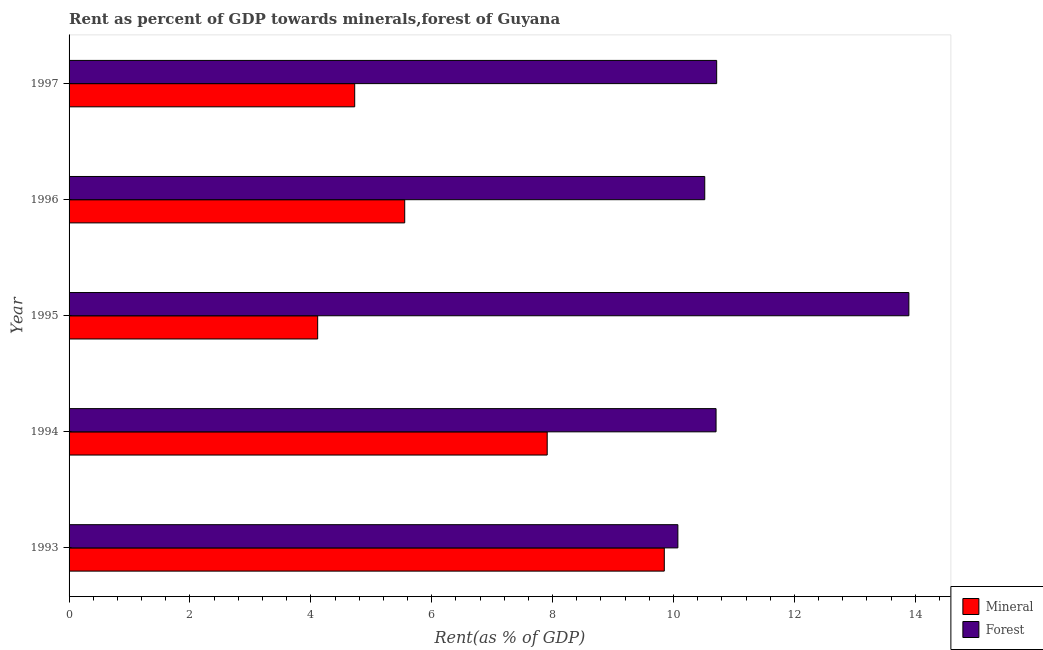How many groups of bars are there?
Make the answer very short. 5. Are the number of bars per tick equal to the number of legend labels?
Give a very brief answer. Yes. Are the number of bars on each tick of the Y-axis equal?
Provide a succinct answer. Yes. What is the mineral rent in 1996?
Provide a short and direct response. 5.55. Across all years, what is the maximum mineral rent?
Offer a very short reply. 9.85. Across all years, what is the minimum forest rent?
Make the answer very short. 10.07. In which year was the forest rent minimum?
Keep it short and to the point. 1993. What is the total mineral rent in the graph?
Your answer should be very brief. 32.15. What is the difference between the mineral rent in 1993 and that in 1997?
Offer a very short reply. 5.12. What is the difference between the mineral rent in 1995 and the forest rent in 1994?
Provide a succinct answer. -6.59. What is the average forest rent per year?
Give a very brief answer. 11.18. In the year 1996, what is the difference between the forest rent and mineral rent?
Your answer should be compact. 4.96. What is the ratio of the mineral rent in 1994 to that in 1995?
Offer a very short reply. 1.92. Is the mineral rent in 1993 less than that in 1997?
Provide a succinct answer. No. What is the difference between the highest and the second highest forest rent?
Keep it short and to the point. 3.18. What is the difference between the highest and the lowest mineral rent?
Offer a very short reply. 5.73. In how many years, is the mineral rent greater than the average mineral rent taken over all years?
Ensure brevity in your answer.  2. Is the sum of the mineral rent in 1993 and 1995 greater than the maximum forest rent across all years?
Your answer should be very brief. Yes. What does the 2nd bar from the top in 1993 represents?
Ensure brevity in your answer.  Mineral. What does the 1st bar from the bottom in 1994 represents?
Provide a succinct answer. Mineral. How many bars are there?
Your answer should be very brief. 10. Are all the bars in the graph horizontal?
Your response must be concise. Yes. Are the values on the major ticks of X-axis written in scientific E-notation?
Offer a very short reply. No. Does the graph contain any zero values?
Your response must be concise. No. Does the graph contain grids?
Provide a short and direct response. No. Where does the legend appear in the graph?
Provide a succinct answer. Bottom right. How are the legend labels stacked?
Keep it short and to the point. Vertical. What is the title of the graph?
Make the answer very short. Rent as percent of GDP towards minerals,forest of Guyana. Does "Working capital" appear as one of the legend labels in the graph?
Your response must be concise. No. What is the label or title of the X-axis?
Ensure brevity in your answer.  Rent(as % of GDP). What is the Rent(as % of GDP) in Mineral in 1993?
Provide a short and direct response. 9.85. What is the Rent(as % of GDP) of Forest in 1993?
Ensure brevity in your answer.  10.07. What is the Rent(as % of GDP) of Mineral in 1994?
Make the answer very short. 7.91. What is the Rent(as % of GDP) in Forest in 1994?
Give a very brief answer. 10.7. What is the Rent(as % of GDP) in Mineral in 1995?
Offer a terse response. 4.11. What is the Rent(as % of GDP) of Forest in 1995?
Ensure brevity in your answer.  13.89. What is the Rent(as % of GDP) in Mineral in 1996?
Offer a very short reply. 5.55. What is the Rent(as % of GDP) in Forest in 1996?
Offer a very short reply. 10.52. What is the Rent(as % of GDP) of Mineral in 1997?
Keep it short and to the point. 4.73. What is the Rent(as % of GDP) in Forest in 1997?
Give a very brief answer. 10.71. Across all years, what is the maximum Rent(as % of GDP) of Mineral?
Your answer should be compact. 9.85. Across all years, what is the maximum Rent(as % of GDP) of Forest?
Your answer should be very brief. 13.89. Across all years, what is the minimum Rent(as % of GDP) of Mineral?
Keep it short and to the point. 4.11. Across all years, what is the minimum Rent(as % of GDP) in Forest?
Give a very brief answer. 10.07. What is the total Rent(as % of GDP) of Mineral in the graph?
Provide a succinct answer. 32.15. What is the total Rent(as % of GDP) of Forest in the graph?
Your answer should be very brief. 55.9. What is the difference between the Rent(as % of GDP) in Mineral in 1993 and that in 1994?
Your answer should be very brief. 1.94. What is the difference between the Rent(as % of GDP) in Forest in 1993 and that in 1994?
Make the answer very short. -0.63. What is the difference between the Rent(as % of GDP) of Mineral in 1993 and that in 1995?
Provide a short and direct response. 5.73. What is the difference between the Rent(as % of GDP) of Forest in 1993 and that in 1995?
Your response must be concise. -3.82. What is the difference between the Rent(as % of GDP) of Mineral in 1993 and that in 1996?
Give a very brief answer. 4.29. What is the difference between the Rent(as % of GDP) in Forest in 1993 and that in 1996?
Provide a short and direct response. -0.44. What is the difference between the Rent(as % of GDP) in Mineral in 1993 and that in 1997?
Offer a terse response. 5.12. What is the difference between the Rent(as % of GDP) in Forest in 1993 and that in 1997?
Make the answer very short. -0.64. What is the difference between the Rent(as % of GDP) in Mineral in 1994 and that in 1995?
Provide a short and direct response. 3.8. What is the difference between the Rent(as % of GDP) of Forest in 1994 and that in 1995?
Offer a very short reply. -3.19. What is the difference between the Rent(as % of GDP) in Mineral in 1994 and that in 1996?
Your response must be concise. 2.36. What is the difference between the Rent(as % of GDP) of Forest in 1994 and that in 1996?
Make the answer very short. 0.19. What is the difference between the Rent(as % of GDP) of Mineral in 1994 and that in 1997?
Provide a succinct answer. 3.18. What is the difference between the Rent(as % of GDP) of Forest in 1994 and that in 1997?
Offer a very short reply. -0.01. What is the difference between the Rent(as % of GDP) of Mineral in 1995 and that in 1996?
Provide a short and direct response. -1.44. What is the difference between the Rent(as % of GDP) of Forest in 1995 and that in 1996?
Make the answer very short. 3.38. What is the difference between the Rent(as % of GDP) of Mineral in 1995 and that in 1997?
Ensure brevity in your answer.  -0.61. What is the difference between the Rent(as % of GDP) in Forest in 1995 and that in 1997?
Make the answer very short. 3.18. What is the difference between the Rent(as % of GDP) of Mineral in 1996 and that in 1997?
Your answer should be very brief. 0.83. What is the difference between the Rent(as % of GDP) in Forest in 1996 and that in 1997?
Give a very brief answer. -0.2. What is the difference between the Rent(as % of GDP) of Mineral in 1993 and the Rent(as % of GDP) of Forest in 1994?
Make the answer very short. -0.86. What is the difference between the Rent(as % of GDP) in Mineral in 1993 and the Rent(as % of GDP) in Forest in 1995?
Offer a very short reply. -4.05. What is the difference between the Rent(as % of GDP) of Mineral in 1993 and the Rent(as % of GDP) of Forest in 1996?
Ensure brevity in your answer.  -0.67. What is the difference between the Rent(as % of GDP) of Mineral in 1993 and the Rent(as % of GDP) of Forest in 1997?
Your answer should be compact. -0.87. What is the difference between the Rent(as % of GDP) of Mineral in 1994 and the Rent(as % of GDP) of Forest in 1995?
Offer a terse response. -5.98. What is the difference between the Rent(as % of GDP) of Mineral in 1994 and the Rent(as % of GDP) of Forest in 1996?
Your answer should be very brief. -2.61. What is the difference between the Rent(as % of GDP) of Mineral in 1994 and the Rent(as % of GDP) of Forest in 1997?
Keep it short and to the point. -2.8. What is the difference between the Rent(as % of GDP) of Mineral in 1995 and the Rent(as % of GDP) of Forest in 1996?
Your answer should be very brief. -6.4. What is the difference between the Rent(as % of GDP) of Mineral in 1995 and the Rent(as % of GDP) of Forest in 1997?
Make the answer very short. -6.6. What is the difference between the Rent(as % of GDP) in Mineral in 1996 and the Rent(as % of GDP) in Forest in 1997?
Provide a succinct answer. -5.16. What is the average Rent(as % of GDP) of Mineral per year?
Provide a short and direct response. 6.43. What is the average Rent(as % of GDP) of Forest per year?
Keep it short and to the point. 11.18. In the year 1993, what is the difference between the Rent(as % of GDP) in Mineral and Rent(as % of GDP) in Forest?
Provide a short and direct response. -0.22. In the year 1994, what is the difference between the Rent(as % of GDP) in Mineral and Rent(as % of GDP) in Forest?
Provide a short and direct response. -2.79. In the year 1995, what is the difference between the Rent(as % of GDP) in Mineral and Rent(as % of GDP) in Forest?
Provide a short and direct response. -9.78. In the year 1996, what is the difference between the Rent(as % of GDP) of Mineral and Rent(as % of GDP) of Forest?
Offer a terse response. -4.96. In the year 1997, what is the difference between the Rent(as % of GDP) in Mineral and Rent(as % of GDP) in Forest?
Offer a very short reply. -5.99. What is the ratio of the Rent(as % of GDP) in Mineral in 1993 to that in 1994?
Your answer should be very brief. 1.24. What is the ratio of the Rent(as % of GDP) in Forest in 1993 to that in 1994?
Provide a short and direct response. 0.94. What is the ratio of the Rent(as % of GDP) of Mineral in 1993 to that in 1995?
Provide a short and direct response. 2.39. What is the ratio of the Rent(as % of GDP) of Forest in 1993 to that in 1995?
Your answer should be compact. 0.72. What is the ratio of the Rent(as % of GDP) of Mineral in 1993 to that in 1996?
Your answer should be compact. 1.77. What is the ratio of the Rent(as % of GDP) in Forest in 1993 to that in 1996?
Ensure brevity in your answer.  0.96. What is the ratio of the Rent(as % of GDP) in Mineral in 1993 to that in 1997?
Your answer should be very brief. 2.08. What is the ratio of the Rent(as % of GDP) of Forest in 1993 to that in 1997?
Offer a very short reply. 0.94. What is the ratio of the Rent(as % of GDP) in Mineral in 1994 to that in 1995?
Provide a short and direct response. 1.92. What is the ratio of the Rent(as % of GDP) of Forest in 1994 to that in 1995?
Make the answer very short. 0.77. What is the ratio of the Rent(as % of GDP) of Mineral in 1994 to that in 1996?
Your response must be concise. 1.42. What is the ratio of the Rent(as % of GDP) of Forest in 1994 to that in 1996?
Your answer should be compact. 1.02. What is the ratio of the Rent(as % of GDP) of Mineral in 1994 to that in 1997?
Offer a very short reply. 1.67. What is the ratio of the Rent(as % of GDP) of Mineral in 1995 to that in 1996?
Provide a short and direct response. 0.74. What is the ratio of the Rent(as % of GDP) of Forest in 1995 to that in 1996?
Offer a very short reply. 1.32. What is the ratio of the Rent(as % of GDP) of Mineral in 1995 to that in 1997?
Keep it short and to the point. 0.87. What is the ratio of the Rent(as % of GDP) of Forest in 1995 to that in 1997?
Your answer should be very brief. 1.3. What is the ratio of the Rent(as % of GDP) in Mineral in 1996 to that in 1997?
Your response must be concise. 1.18. What is the ratio of the Rent(as % of GDP) in Forest in 1996 to that in 1997?
Provide a succinct answer. 0.98. What is the difference between the highest and the second highest Rent(as % of GDP) of Mineral?
Make the answer very short. 1.94. What is the difference between the highest and the second highest Rent(as % of GDP) in Forest?
Provide a short and direct response. 3.18. What is the difference between the highest and the lowest Rent(as % of GDP) of Mineral?
Give a very brief answer. 5.73. What is the difference between the highest and the lowest Rent(as % of GDP) in Forest?
Your response must be concise. 3.82. 